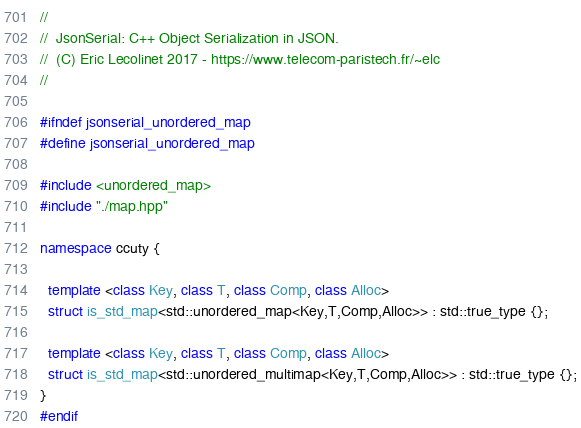<code> <loc_0><loc_0><loc_500><loc_500><_C++_>//
//  JsonSerial: C++ Object Serialization in JSON.
//  (C) Eric Lecolinet 2017 - https://www.telecom-paristech.fr/~elc
//

#ifndef jsonserial_unordered_map
#define jsonserial_unordered_map

#include <unordered_map>
#include "./map.hpp"

namespace ccuty {
  
  template <class Key, class T, class Comp, class Alloc>
  struct is_std_map<std::unordered_map<Key,T,Comp,Alloc>> : std::true_type {};

  template <class Key, class T, class Comp, class Alloc>
  struct is_std_map<std::unordered_multimap<Key,T,Comp,Alloc>> : std::true_type {};
}
#endif
</code> 